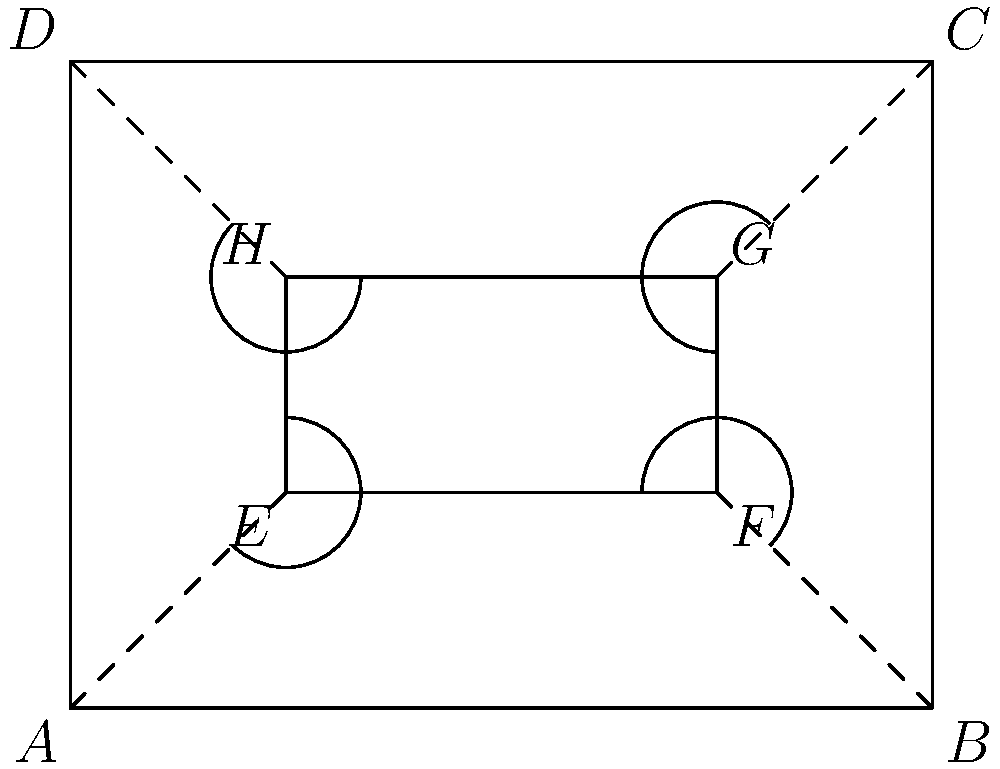During an underwater expedition, you're tasked with analyzing the geometric properties of a new diving equipment configuration. The outer frame of the equipment is represented by rectangle $ABCD$, while the inner compartment is represented by rectangle $EFGH$. If the dashed lines represent support struts connecting the outer frame to the inner compartment, which pairs of angles are congruent? To determine the congruent angles, let's analyze the geometric properties of the figure step-by-step:

1. The figure shows two rectangles: outer rectangle $ABCD$ and inner rectangle $EFGH$.

2. The dashed lines ($AE$, $BF$, $CG$, and $DH$) represent the support struts connecting the outer frame to the inner compartment.

3. In a rectangle, all interior angles are 90°. This applies to both $ABCD$ and $EFGH$.

4. The dashed lines create four pairs of angles: $\angle AEH$, $\angle BFE$, $\angle CGF$, and $\angle DHG$.

5. These angles are formed by the intersection of parallel lines (the sides of the rectangles) with a transversal (the dashed lines).

6. When parallel lines are cut by a transversal, corresponding angles are congruent.

7. Therefore, the following pairs of angles are congruent:
   - $\angle AEH \cong \angle CGF$ (alternate interior angles)
   - $\angle BFE \cong \angle DHG$ (alternate interior angles)

8. Additionally, vertical angles are always congruent, so:
   - $\angle AEH \cong \angle BFE$
   - $\angle CGF \cong \angle DHG$

9. By the transitive property of congruence, we can conclude that all four angles ($\angle AEH$, $\angle BFE$, $\angle CGF$, and $\angle DHG$) are congruent to each other.
Answer: $\angle AEH \cong \angle BFE \cong \angle CGF \cong \angle DHG$ 